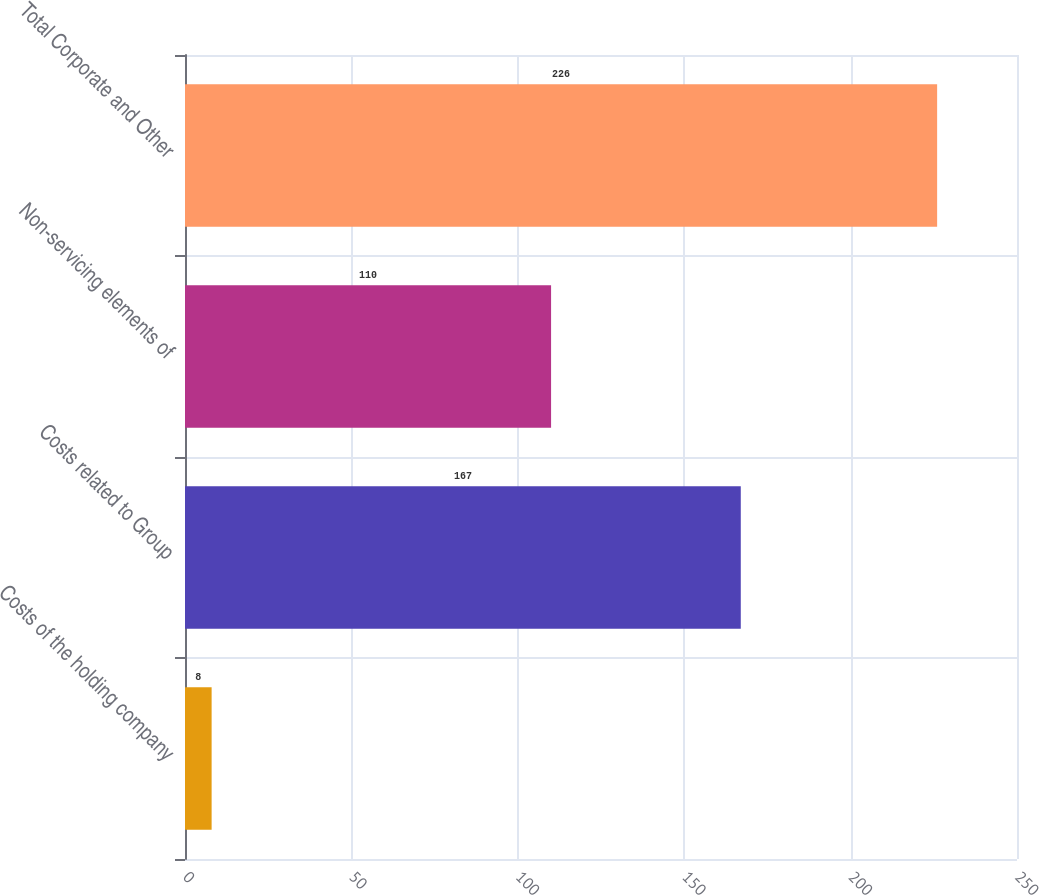Convert chart. <chart><loc_0><loc_0><loc_500><loc_500><bar_chart><fcel>Costs of the holding company<fcel>Costs related to Group<fcel>Non-servicing elements of<fcel>Total Corporate and Other<nl><fcel>8<fcel>167<fcel>110<fcel>226<nl></chart> 